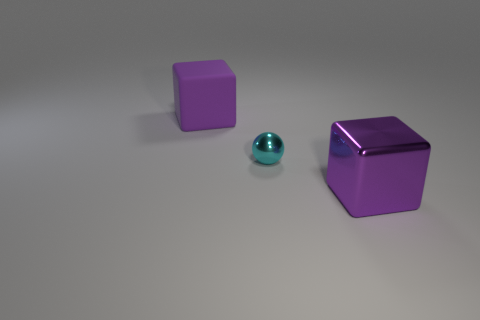Add 3 small green balls. How many objects exist? 6 Subtract all balls. How many objects are left? 2 Subtract all shiny blocks. Subtract all purple cubes. How many objects are left? 0 Add 1 metallic blocks. How many metallic blocks are left? 2 Add 1 small gray cylinders. How many small gray cylinders exist? 1 Subtract 0 blue spheres. How many objects are left? 3 